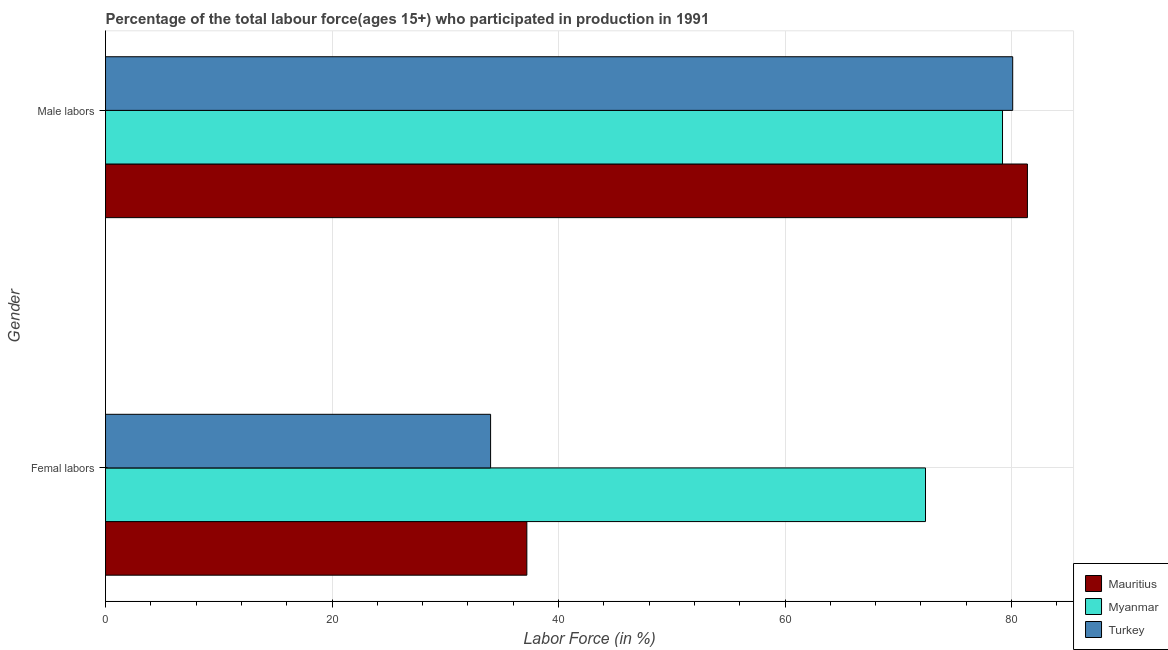How many different coloured bars are there?
Provide a succinct answer. 3. Are the number of bars on each tick of the Y-axis equal?
Provide a succinct answer. Yes. What is the label of the 2nd group of bars from the top?
Your response must be concise. Femal labors. What is the percentage of female labor force in Myanmar?
Keep it short and to the point. 72.4. Across all countries, what is the maximum percentage of female labor force?
Your answer should be very brief. 72.4. Across all countries, what is the minimum percentage of male labour force?
Your response must be concise. 79.2. In which country was the percentage of female labor force maximum?
Your response must be concise. Myanmar. In which country was the percentage of male labour force minimum?
Provide a succinct answer. Myanmar. What is the total percentage of male labour force in the graph?
Provide a succinct answer. 240.7. What is the difference between the percentage of female labor force in Myanmar and that in Mauritius?
Offer a terse response. 35.2. What is the difference between the percentage of female labor force in Turkey and the percentage of male labour force in Mauritius?
Keep it short and to the point. -47.4. What is the average percentage of male labour force per country?
Provide a succinct answer. 80.23. What is the difference between the percentage of male labour force and percentage of female labor force in Turkey?
Your answer should be compact. 46.1. In how many countries, is the percentage of male labour force greater than 72 %?
Your answer should be compact. 3. What is the ratio of the percentage of female labor force in Myanmar to that in Turkey?
Provide a succinct answer. 2.13. What does the 2nd bar from the bottom in Male labors represents?
Provide a succinct answer. Myanmar. How many bars are there?
Make the answer very short. 6. Are the values on the major ticks of X-axis written in scientific E-notation?
Offer a very short reply. No. Does the graph contain any zero values?
Keep it short and to the point. No. Where does the legend appear in the graph?
Provide a succinct answer. Bottom right. How many legend labels are there?
Ensure brevity in your answer.  3. What is the title of the graph?
Provide a short and direct response. Percentage of the total labour force(ages 15+) who participated in production in 1991. What is the Labor Force (in %) in Mauritius in Femal labors?
Provide a succinct answer. 37.2. What is the Labor Force (in %) in Myanmar in Femal labors?
Your answer should be compact. 72.4. What is the Labor Force (in %) in Turkey in Femal labors?
Offer a terse response. 34. What is the Labor Force (in %) of Mauritius in Male labors?
Offer a very short reply. 81.4. What is the Labor Force (in %) in Myanmar in Male labors?
Keep it short and to the point. 79.2. What is the Labor Force (in %) in Turkey in Male labors?
Ensure brevity in your answer.  80.1. Across all Gender, what is the maximum Labor Force (in %) of Mauritius?
Give a very brief answer. 81.4. Across all Gender, what is the maximum Labor Force (in %) of Myanmar?
Offer a very short reply. 79.2. Across all Gender, what is the maximum Labor Force (in %) in Turkey?
Keep it short and to the point. 80.1. Across all Gender, what is the minimum Labor Force (in %) of Mauritius?
Ensure brevity in your answer.  37.2. Across all Gender, what is the minimum Labor Force (in %) of Myanmar?
Provide a short and direct response. 72.4. Across all Gender, what is the minimum Labor Force (in %) in Turkey?
Offer a terse response. 34. What is the total Labor Force (in %) of Mauritius in the graph?
Make the answer very short. 118.6. What is the total Labor Force (in %) of Myanmar in the graph?
Make the answer very short. 151.6. What is the total Labor Force (in %) in Turkey in the graph?
Offer a very short reply. 114.1. What is the difference between the Labor Force (in %) of Mauritius in Femal labors and that in Male labors?
Provide a succinct answer. -44.2. What is the difference between the Labor Force (in %) in Turkey in Femal labors and that in Male labors?
Your answer should be compact. -46.1. What is the difference between the Labor Force (in %) of Mauritius in Femal labors and the Labor Force (in %) of Myanmar in Male labors?
Your answer should be very brief. -42. What is the difference between the Labor Force (in %) in Mauritius in Femal labors and the Labor Force (in %) in Turkey in Male labors?
Your response must be concise. -42.9. What is the average Labor Force (in %) in Mauritius per Gender?
Offer a very short reply. 59.3. What is the average Labor Force (in %) of Myanmar per Gender?
Make the answer very short. 75.8. What is the average Labor Force (in %) of Turkey per Gender?
Give a very brief answer. 57.05. What is the difference between the Labor Force (in %) in Mauritius and Labor Force (in %) in Myanmar in Femal labors?
Make the answer very short. -35.2. What is the difference between the Labor Force (in %) in Myanmar and Labor Force (in %) in Turkey in Femal labors?
Your response must be concise. 38.4. What is the difference between the Labor Force (in %) in Mauritius and Labor Force (in %) in Myanmar in Male labors?
Your answer should be compact. 2.2. What is the difference between the Labor Force (in %) in Myanmar and Labor Force (in %) in Turkey in Male labors?
Your answer should be very brief. -0.9. What is the ratio of the Labor Force (in %) of Mauritius in Femal labors to that in Male labors?
Make the answer very short. 0.46. What is the ratio of the Labor Force (in %) of Myanmar in Femal labors to that in Male labors?
Provide a succinct answer. 0.91. What is the ratio of the Labor Force (in %) in Turkey in Femal labors to that in Male labors?
Offer a very short reply. 0.42. What is the difference between the highest and the second highest Labor Force (in %) in Mauritius?
Provide a short and direct response. 44.2. What is the difference between the highest and the second highest Labor Force (in %) in Turkey?
Give a very brief answer. 46.1. What is the difference between the highest and the lowest Labor Force (in %) in Mauritius?
Give a very brief answer. 44.2. What is the difference between the highest and the lowest Labor Force (in %) of Myanmar?
Offer a terse response. 6.8. What is the difference between the highest and the lowest Labor Force (in %) of Turkey?
Your answer should be compact. 46.1. 